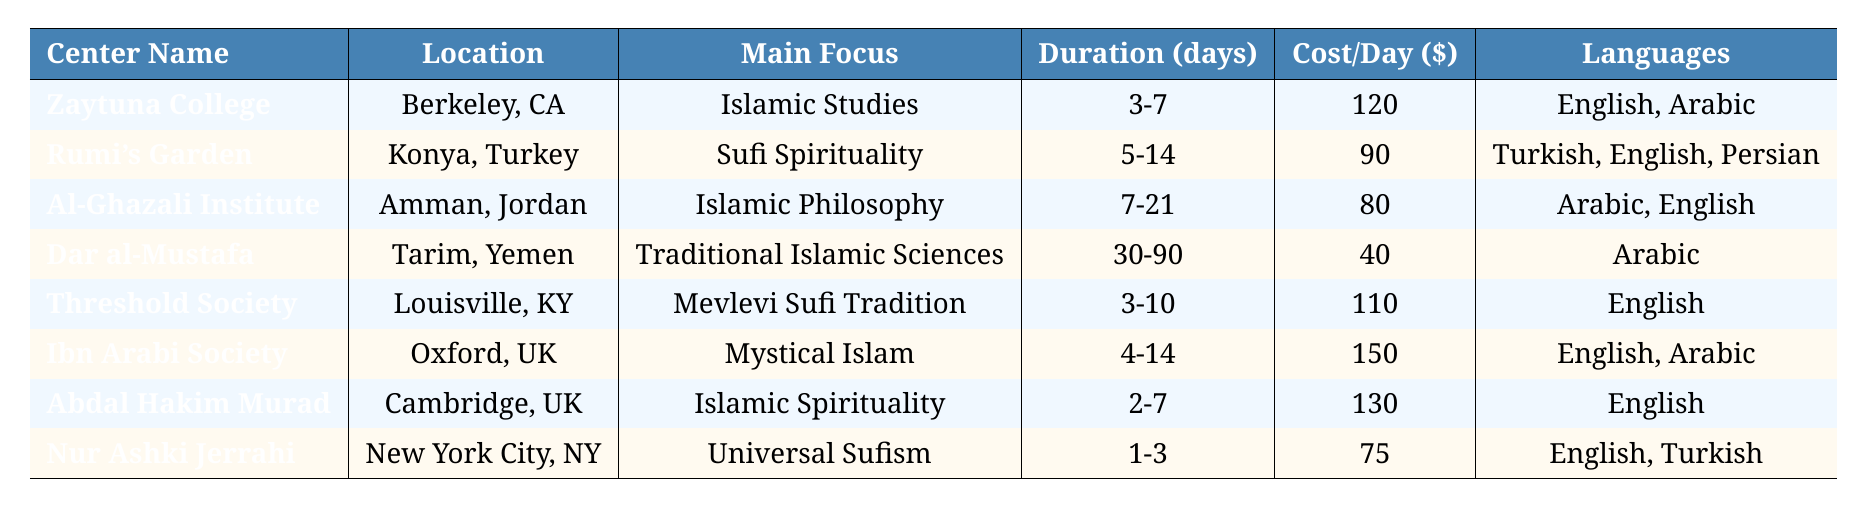What is the main focus of Rumi's Garden? By referring to the table, I can see that Rumi's Garden has "Sufi Spirituality" listed under the main focus column.
Answer: Sufi Spirituality Which retreat center has the highest cost per day? Examining the cost per day column in the table, Ibn Arabi Society at $150 per day is the highest cost.
Answer: Ibn Arabi Society How many languages are spoken at Dar al-Mustafa? Checking the languages column, it shows that the only language at Dar al-Mustafa is Arabic, indicating just one language is spoken.
Answer: 1 What is the average cost per day of the retreat centers? To find the average, add the costs (120 + 90 + 80 + 40 + 110 + 150 + 130 + 75 = 795) and divide by 8 (number of centers), giving an average cost of $99.38.
Answer: 99.38 Which center has a duration of 30-90 days? Looking through the duration column, I see that only Dar al-Mustafa has a duration of 30-90 days.
Answer: Dar al-Mustafa What dietary options are available at Ibn Arabi Society Retreat? The table indicates that Ibn Arabi Society offers "Halal" and "Vegetarian" as dietary options.
Answer: Halal, Vegetarian Is it true that all retreat centers provide halal food? Checking the dietary options for each center, all listed have at least "Halal" included, confirming the statement is true.
Answer: Yes What is the total capacity of the centers located in the United States? Adding the capacities of Zaytuna College (50), Threshold Society (25), Ibn Arabi Society (35), and Nur Ashki Jerrahi (20) gives a total of 130.
Answer: 130 How long can one stay at Al-Ghazali Institute at a minimum? The table states that the minimum duration listed for Al-Ghazali Institute is 7 days.
Answer: 7 days What activities are offered at Threshold Society Retreat Center? The retreat center's activities listed in the table include Sufi zikr, contemplative poetry sessions, and nature walks.
Answer: Sufi zikr, contemplative poetry sessions, nature walks 